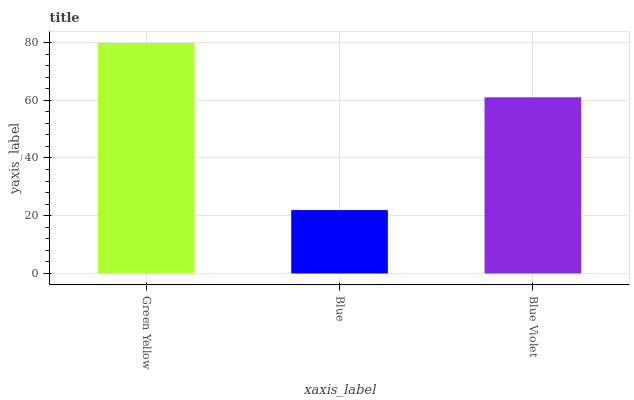Is Blue the minimum?
Answer yes or no. Yes. Is Green Yellow the maximum?
Answer yes or no. Yes. Is Blue Violet the minimum?
Answer yes or no. No. Is Blue Violet the maximum?
Answer yes or no. No. Is Blue Violet greater than Blue?
Answer yes or no. Yes. Is Blue less than Blue Violet?
Answer yes or no. Yes. Is Blue greater than Blue Violet?
Answer yes or no. No. Is Blue Violet less than Blue?
Answer yes or no. No. Is Blue Violet the high median?
Answer yes or no. Yes. Is Blue Violet the low median?
Answer yes or no. Yes. Is Green Yellow the high median?
Answer yes or no. No. Is Blue the low median?
Answer yes or no. No. 